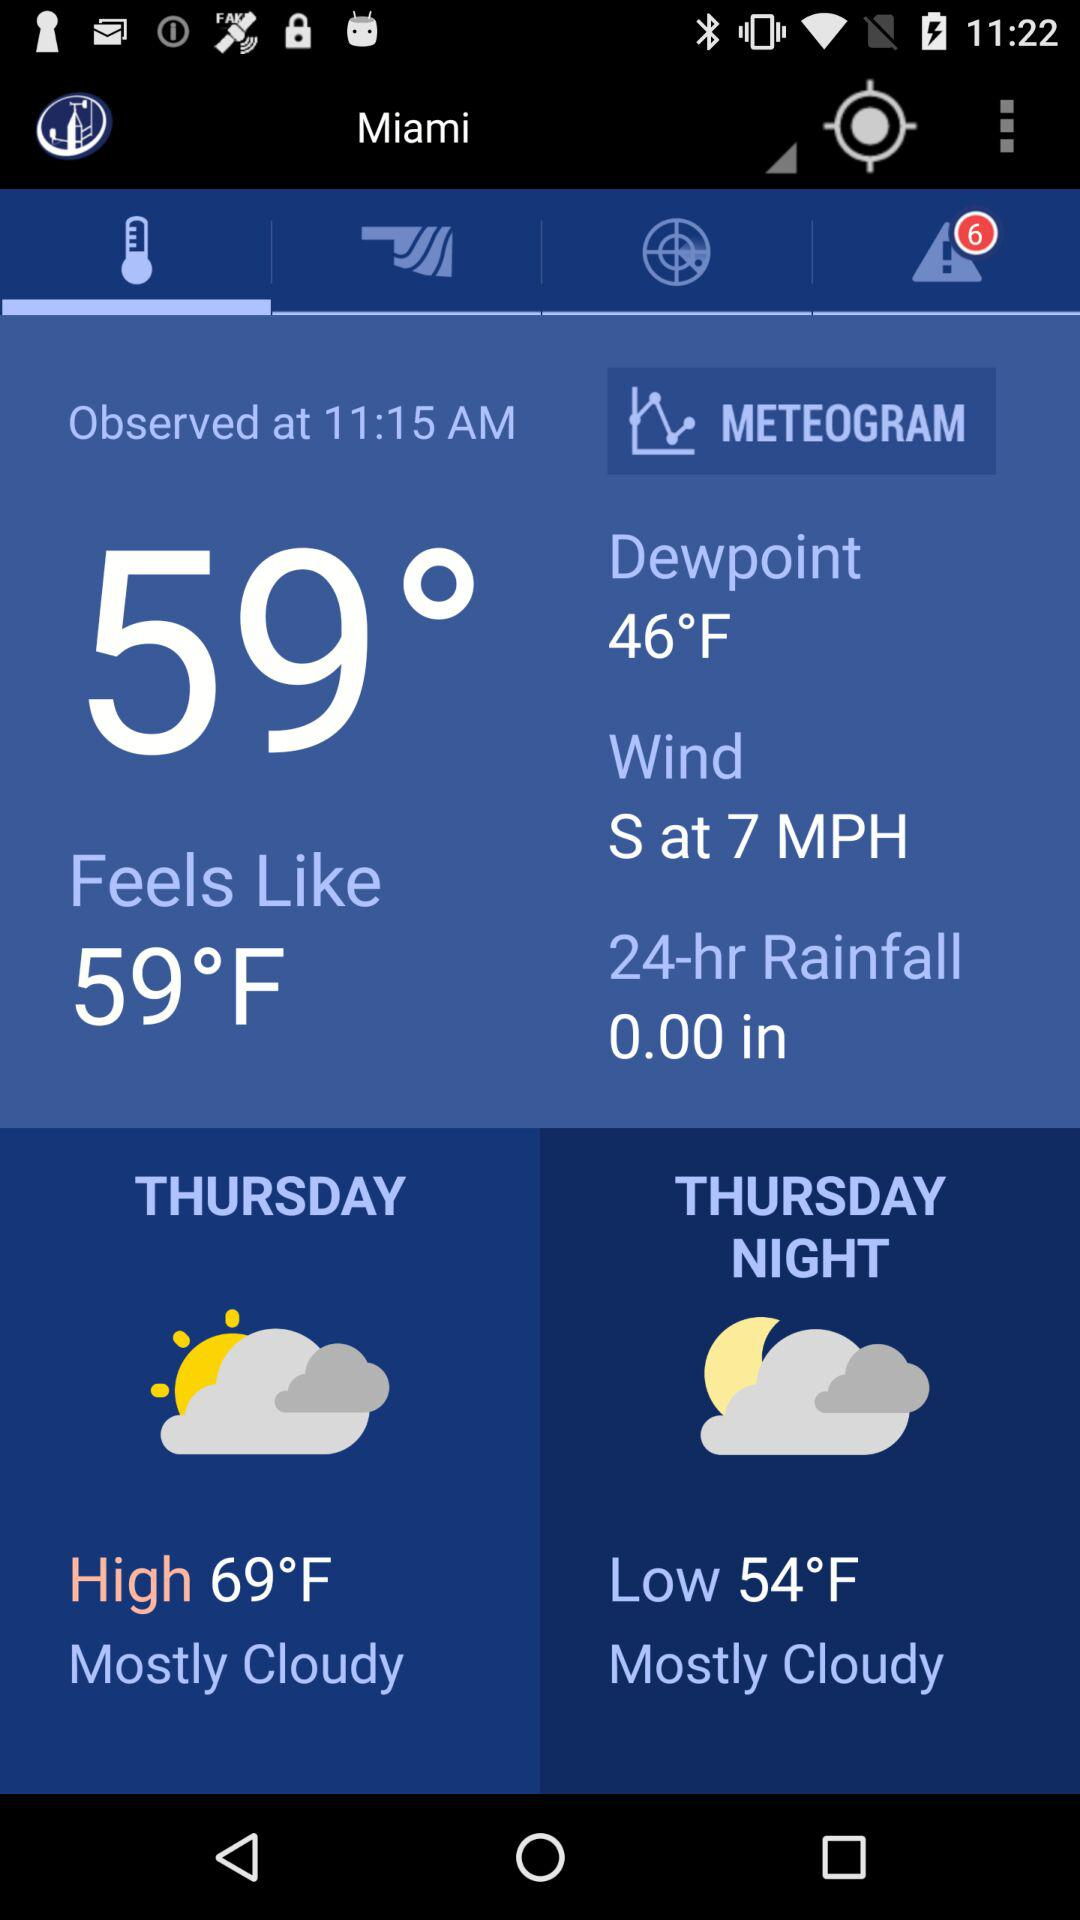At what time is the temperature observed? The temperature is observed at 11:15 AM. 